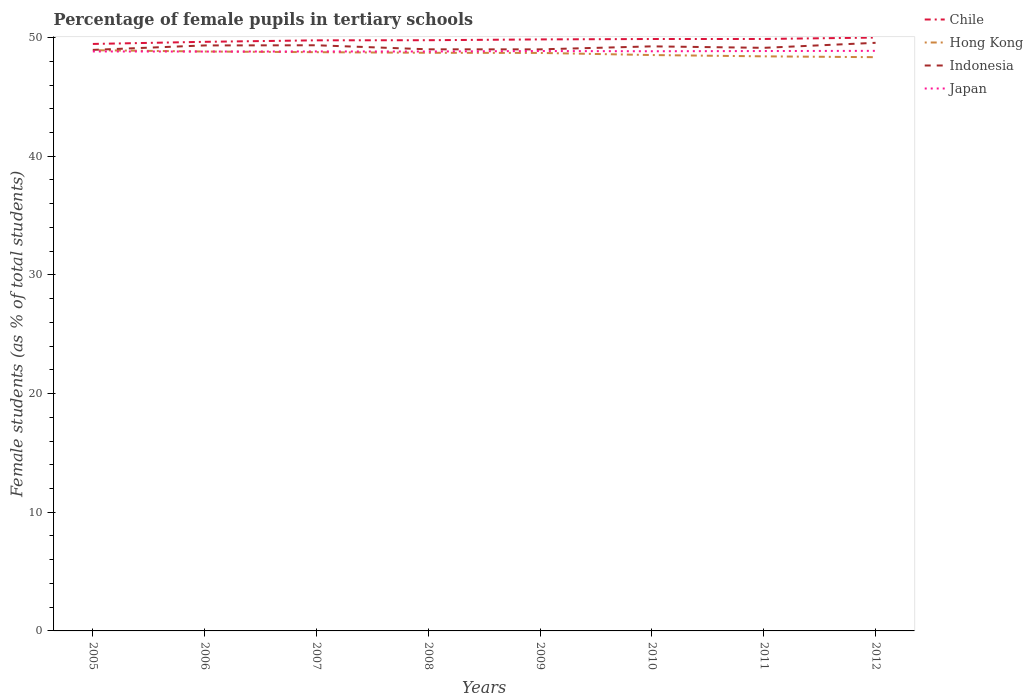How many different coloured lines are there?
Your response must be concise. 4. Across all years, what is the maximum percentage of female pupils in tertiary schools in Japan?
Offer a terse response. 48.82. In which year was the percentage of female pupils in tertiary schools in Japan maximum?
Keep it short and to the point. 2006. What is the total percentage of female pupils in tertiary schools in Indonesia in the graph?
Provide a succinct answer. -0.22. What is the difference between the highest and the second highest percentage of female pupils in tertiary schools in Japan?
Provide a succinct answer. 0.06. What is the difference between the highest and the lowest percentage of female pupils in tertiary schools in Japan?
Give a very brief answer. 4. What is the difference between two consecutive major ticks on the Y-axis?
Provide a succinct answer. 10. Are the values on the major ticks of Y-axis written in scientific E-notation?
Offer a very short reply. No. Does the graph contain any zero values?
Give a very brief answer. No. Does the graph contain grids?
Keep it short and to the point. No. What is the title of the graph?
Your answer should be very brief. Percentage of female pupils in tertiary schools. Does "Tajikistan" appear as one of the legend labels in the graph?
Provide a succinct answer. No. What is the label or title of the X-axis?
Provide a short and direct response. Years. What is the label or title of the Y-axis?
Make the answer very short. Female students (as % of total students). What is the Female students (as % of total students) in Chile in 2005?
Ensure brevity in your answer.  49.46. What is the Female students (as % of total students) of Hong Kong in 2005?
Your response must be concise. 48.94. What is the Female students (as % of total students) of Indonesia in 2005?
Give a very brief answer. 48.96. What is the Female students (as % of total students) of Japan in 2005?
Provide a succinct answer. 48.83. What is the Female students (as % of total students) in Chile in 2006?
Provide a succinct answer. 49.64. What is the Female students (as % of total students) of Hong Kong in 2006?
Offer a very short reply. 48.82. What is the Female students (as % of total students) in Indonesia in 2006?
Your response must be concise. 49.34. What is the Female students (as % of total students) in Japan in 2006?
Give a very brief answer. 48.82. What is the Female students (as % of total students) of Chile in 2007?
Your answer should be compact. 49.77. What is the Female students (as % of total students) in Hong Kong in 2007?
Your answer should be compact. 48.77. What is the Female students (as % of total students) in Indonesia in 2007?
Your answer should be very brief. 49.35. What is the Female students (as % of total students) in Japan in 2007?
Your answer should be compact. 48.83. What is the Female students (as % of total students) of Chile in 2008?
Offer a terse response. 49.78. What is the Female students (as % of total students) in Hong Kong in 2008?
Provide a short and direct response. 48.72. What is the Female students (as % of total students) in Indonesia in 2008?
Your response must be concise. 49.01. What is the Female students (as % of total students) in Japan in 2008?
Provide a short and direct response. 48.83. What is the Female students (as % of total students) in Chile in 2009?
Your answer should be very brief. 49.84. What is the Female students (as % of total students) in Hong Kong in 2009?
Your answer should be compact. 48.71. What is the Female students (as % of total students) in Indonesia in 2009?
Provide a succinct answer. 49.01. What is the Female students (as % of total students) in Japan in 2009?
Provide a succinct answer. 48.87. What is the Female students (as % of total students) in Chile in 2010?
Your answer should be compact. 49.88. What is the Female students (as % of total students) of Hong Kong in 2010?
Provide a succinct answer. 48.53. What is the Female students (as % of total students) in Indonesia in 2010?
Your answer should be compact. 49.26. What is the Female students (as % of total students) in Japan in 2010?
Your response must be concise. 48.85. What is the Female students (as % of total students) in Chile in 2011?
Give a very brief answer. 49.88. What is the Female students (as % of total students) of Hong Kong in 2011?
Keep it short and to the point. 48.42. What is the Female students (as % of total students) in Indonesia in 2011?
Your answer should be compact. 49.13. What is the Female students (as % of total students) of Japan in 2011?
Offer a terse response. 48.87. What is the Female students (as % of total students) in Chile in 2012?
Offer a very short reply. 50. What is the Female students (as % of total students) in Hong Kong in 2012?
Your answer should be very brief. 48.35. What is the Female students (as % of total students) of Indonesia in 2012?
Offer a very short reply. 49.56. What is the Female students (as % of total students) in Japan in 2012?
Keep it short and to the point. 48.88. Across all years, what is the maximum Female students (as % of total students) in Chile?
Provide a succinct answer. 50. Across all years, what is the maximum Female students (as % of total students) of Hong Kong?
Provide a short and direct response. 48.94. Across all years, what is the maximum Female students (as % of total students) in Indonesia?
Give a very brief answer. 49.56. Across all years, what is the maximum Female students (as % of total students) of Japan?
Provide a succinct answer. 48.88. Across all years, what is the minimum Female students (as % of total students) of Chile?
Give a very brief answer. 49.46. Across all years, what is the minimum Female students (as % of total students) of Hong Kong?
Offer a very short reply. 48.35. Across all years, what is the minimum Female students (as % of total students) in Indonesia?
Your answer should be very brief. 48.96. Across all years, what is the minimum Female students (as % of total students) in Japan?
Ensure brevity in your answer.  48.82. What is the total Female students (as % of total students) in Chile in the graph?
Ensure brevity in your answer.  398.25. What is the total Female students (as % of total students) of Hong Kong in the graph?
Give a very brief answer. 389.24. What is the total Female students (as % of total students) in Indonesia in the graph?
Offer a very short reply. 393.62. What is the total Female students (as % of total students) in Japan in the graph?
Ensure brevity in your answer.  390.77. What is the difference between the Female students (as % of total students) in Chile in 2005 and that in 2006?
Your answer should be very brief. -0.18. What is the difference between the Female students (as % of total students) in Hong Kong in 2005 and that in 2006?
Ensure brevity in your answer.  0.11. What is the difference between the Female students (as % of total students) of Indonesia in 2005 and that in 2006?
Make the answer very short. -0.37. What is the difference between the Female students (as % of total students) of Japan in 2005 and that in 2006?
Offer a terse response. 0.01. What is the difference between the Female students (as % of total students) of Chile in 2005 and that in 2007?
Provide a short and direct response. -0.3. What is the difference between the Female students (as % of total students) of Hong Kong in 2005 and that in 2007?
Your answer should be compact. 0.17. What is the difference between the Female students (as % of total students) in Indonesia in 2005 and that in 2007?
Ensure brevity in your answer.  -0.39. What is the difference between the Female students (as % of total students) in Japan in 2005 and that in 2007?
Ensure brevity in your answer.  -0. What is the difference between the Female students (as % of total students) of Chile in 2005 and that in 2008?
Your response must be concise. -0.31. What is the difference between the Female students (as % of total students) in Hong Kong in 2005 and that in 2008?
Offer a terse response. 0.22. What is the difference between the Female students (as % of total students) in Indonesia in 2005 and that in 2008?
Ensure brevity in your answer.  -0.05. What is the difference between the Female students (as % of total students) in Japan in 2005 and that in 2008?
Give a very brief answer. 0. What is the difference between the Female students (as % of total students) in Chile in 2005 and that in 2009?
Offer a very short reply. -0.38. What is the difference between the Female students (as % of total students) in Hong Kong in 2005 and that in 2009?
Your answer should be very brief. 0.23. What is the difference between the Female students (as % of total students) in Indonesia in 2005 and that in 2009?
Your response must be concise. -0.04. What is the difference between the Female students (as % of total students) in Japan in 2005 and that in 2009?
Offer a terse response. -0.03. What is the difference between the Female students (as % of total students) in Chile in 2005 and that in 2010?
Give a very brief answer. -0.42. What is the difference between the Female students (as % of total students) of Hong Kong in 2005 and that in 2010?
Provide a short and direct response. 0.41. What is the difference between the Female students (as % of total students) of Indonesia in 2005 and that in 2010?
Your response must be concise. -0.3. What is the difference between the Female students (as % of total students) in Japan in 2005 and that in 2010?
Give a very brief answer. -0.02. What is the difference between the Female students (as % of total students) of Chile in 2005 and that in 2011?
Keep it short and to the point. -0.42. What is the difference between the Female students (as % of total students) in Hong Kong in 2005 and that in 2011?
Make the answer very short. 0.52. What is the difference between the Female students (as % of total students) of Indonesia in 2005 and that in 2011?
Give a very brief answer. -0.17. What is the difference between the Female students (as % of total students) in Japan in 2005 and that in 2011?
Your answer should be compact. -0.03. What is the difference between the Female students (as % of total students) of Chile in 2005 and that in 2012?
Provide a short and direct response. -0.54. What is the difference between the Female students (as % of total students) of Hong Kong in 2005 and that in 2012?
Your response must be concise. 0.59. What is the difference between the Female students (as % of total students) of Indonesia in 2005 and that in 2012?
Give a very brief answer. -0.6. What is the difference between the Female students (as % of total students) of Japan in 2005 and that in 2012?
Keep it short and to the point. -0.05. What is the difference between the Female students (as % of total students) of Chile in 2006 and that in 2007?
Your response must be concise. -0.13. What is the difference between the Female students (as % of total students) in Hong Kong in 2006 and that in 2007?
Your answer should be compact. 0.06. What is the difference between the Female students (as % of total students) of Indonesia in 2006 and that in 2007?
Offer a terse response. -0.01. What is the difference between the Female students (as % of total students) of Japan in 2006 and that in 2007?
Your response must be concise. -0.01. What is the difference between the Female students (as % of total students) in Chile in 2006 and that in 2008?
Your answer should be compact. -0.14. What is the difference between the Female students (as % of total students) in Hong Kong in 2006 and that in 2008?
Keep it short and to the point. 0.11. What is the difference between the Female students (as % of total students) of Indonesia in 2006 and that in 2008?
Provide a succinct answer. 0.33. What is the difference between the Female students (as % of total students) in Japan in 2006 and that in 2008?
Your response must be concise. -0. What is the difference between the Female students (as % of total students) in Chile in 2006 and that in 2009?
Your answer should be very brief. -0.2. What is the difference between the Female students (as % of total students) of Hong Kong in 2006 and that in 2009?
Keep it short and to the point. 0.12. What is the difference between the Female students (as % of total students) in Indonesia in 2006 and that in 2009?
Provide a succinct answer. 0.33. What is the difference between the Female students (as % of total students) of Japan in 2006 and that in 2009?
Provide a short and direct response. -0.04. What is the difference between the Female students (as % of total students) of Chile in 2006 and that in 2010?
Offer a terse response. -0.24. What is the difference between the Female students (as % of total students) of Hong Kong in 2006 and that in 2010?
Offer a very short reply. 0.3. What is the difference between the Female students (as % of total students) of Indonesia in 2006 and that in 2010?
Your answer should be very brief. 0.08. What is the difference between the Female students (as % of total students) of Japan in 2006 and that in 2010?
Your response must be concise. -0.02. What is the difference between the Female students (as % of total students) in Chile in 2006 and that in 2011?
Ensure brevity in your answer.  -0.24. What is the difference between the Female students (as % of total students) in Hong Kong in 2006 and that in 2011?
Your answer should be compact. 0.41. What is the difference between the Female students (as % of total students) of Indonesia in 2006 and that in 2011?
Keep it short and to the point. 0.2. What is the difference between the Female students (as % of total students) of Japan in 2006 and that in 2011?
Keep it short and to the point. -0.04. What is the difference between the Female students (as % of total students) of Chile in 2006 and that in 2012?
Offer a very short reply. -0.36. What is the difference between the Female students (as % of total students) in Hong Kong in 2006 and that in 2012?
Offer a very short reply. 0.48. What is the difference between the Female students (as % of total students) in Indonesia in 2006 and that in 2012?
Your answer should be very brief. -0.22. What is the difference between the Female students (as % of total students) of Japan in 2006 and that in 2012?
Make the answer very short. -0.06. What is the difference between the Female students (as % of total students) in Chile in 2007 and that in 2008?
Offer a very short reply. -0.01. What is the difference between the Female students (as % of total students) in Hong Kong in 2007 and that in 2008?
Your answer should be compact. 0.05. What is the difference between the Female students (as % of total students) of Indonesia in 2007 and that in 2008?
Your response must be concise. 0.34. What is the difference between the Female students (as % of total students) of Japan in 2007 and that in 2008?
Keep it short and to the point. 0.01. What is the difference between the Female students (as % of total students) of Chile in 2007 and that in 2009?
Your answer should be compact. -0.08. What is the difference between the Female students (as % of total students) of Hong Kong in 2007 and that in 2009?
Provide a succinct answer. 0.06. What is the difference between the Female students (as % of total students) of Indonesia in 2007 and that in 2009?
Provide a short and direct response. 0.34. What is the difference between the Female students (as % of total students) of Japan in 2007 and that in 2009?
Give a very brief answer. -0.03. What is the difference between the Female students (as % of total students) of Chile in 2007 and that in 2010?
Offer a terse response. -0.11. What is the difference between the Female students (as % of total students) in Hong Kong in 2007 and that in 2010?
Provide a succinct answer. 0.24. What is the difference between the Female students (as % of total students) in Indonesia in 2007 and that in 2010?
Offer a very short reply. 0.09. What is the difference between the Female students (as % of total students) of Japan in 2007 and that in 2010?
Keep it short and to the point. -0.01. What is the difference between the Female students (as % of total students) in Chile in 2007 and that in 2011?
Give a very brief answer. -0.11. What is the difference between the Female students (as % of total students) of Hong Kong in 2007 and that in 2011?
Provide a short and direct response. 0.35. What is the difference between the Female students (as % of total students) in Indonesia in 2007 and that in 2011?
Ensure brevity in your answer.  0.22. What is the difference between the Female students (as % of total students) of Japan in 2007 and that in 2011?
Give a very brief answer. -0.03. What is the difference between the Female students (as % of total students) of Chile in 2007 and that in 2012?
Keep it short and to the point. -0.23. What is the difference between the Female students (as % of total students) of Hong Kong in 2007 and that in 2012?
Keep it short and to the point. 0.42. What is the difference between the Female students (as % of total students) in Indonesia in 2007 and that in 2012?
Offer a terse response. -0.21. What is the difference between the Female students (as % of total students) in Japan in 2007 and that in 2012?
Offer a very short reply. -0.05. What is the difference between the Female students (as % of total students) of Chile in 2008 and that in 2009?
Keep it short and to the point. -0.07. What is the difference between the Female students (as % of total students) in Hong Kong in 2008 and that in 2009?
Ensure brevity in your answer.  0.01. What is the difference between the Female students (as % of total students) in Indonesia in 2008 and that in 2009?
Your answer should be very brief. 0. What is the difference between the Female students (as % of total students) in Japan in 2008 and that in 2009?
Keep it short and to the point. -0.04. What is the difference between the Female students (as % of total students) of Chile in 2008 and that in 2010?
Give a very brief answer. -0.1. What is the difference between the Female students (as % of total students) in Hong Kong in 2008 and that in 2010?
Make the answer very short. 0.19. What is the difference between the Female students (as % of total students) in Indonesia in 2008 and that in 2010?
Offer a very short reply. -0.25. What is the difference between the Female students (as % of total students) in Japan in 2008 and that in 2010?
Offer a terse response. -0.02. What is the difference between the Female students (as % of total students) of Chile in 2008 and that in 2011?
Make the answer very short. -0.1. What is the difference between the Female students (as % of total students) in Hong Kong in 2008 and that in 2011?
Keep it short and to the point. 0.3. What is the difference between the Female students (as % of total students) in Indonesia in 2008 and that in 2011?
Keep it short and to the point. -0.12. What is the difference between the Female students (as % of total students) of Japan in 2008 and that in 2011?
Keep it short and to the point. -0.04. What is the difference between the Female students (as % of total students) in Chile in 2008 and that in 2012?
Your response must be concise. -0.22. What is the difference between the Female students (as % of total students) of Hong Kong in 2008 and that in 2012?
Give a very brief answer. 0.37. What is the difference between the Female students (as % of total students) of Indonesia in 2008 and that in 2012?
Your answer should be very brief. -0.55. What is the difference between the Female students (as % of total students) of Japan in 2008 and that in 2012?
Your answer should be very brief. -0.05. What is the difference between the Female students (as % of total students) in Chile in 2009 and that in 2010?
Ensure brevity in your answer.  -0.03. What is the difference between the Female students (as % of total students) of Hong Kong in 2009 and that in 2010?
Make the answer very short. 0.18. What is the difference between the Female students (as % of total students) of Indonesia in 2009 and that in 2010?
Your response must be concise. -0.25. What is the difference between the Female students (as % of total students) in Japan in 2009 and that in 2010?
Provide a succinct answer. 0.02. What is the difference between the Female students (as % of total students) of Chile in 2009 and that in 2011?
Your answer should be compact. -0.04. What is the difference between the Female students (as % of total students) of Hong Kong in 2009 and that in 2011?
Keep it short and to the point. 0.29. What is the difference between the Female students (as % of total students) in Indonesia in 2009 and that in 2011?
Offer a terse response. -0.13. What is the difference between the Female students (as % of total students) of Japan in 2009 and that in 2011?
Your answer should be compact. 0. What is the difference between the Female students (as % of total students) of Chile in 2009 and that in 2012?
Provide a succinct answer. -0.16. What is the difference between the Female students (as % of total students) in Hong Kong in 2009 and that in 2012?
Offer a terse response. 0.36. What is the difference between the Female students (as % of total students) of Indonesia in 2009 and that in 2012?
Offer a terse response. -0.55. What is the difference between the Female students (as % of total students) in Japan in 2009 and that in 2012?
Your answer should be very brief. -0.02. What is the difference between the Female students (as % of total students) in Chile in 2010 and that in 2011?
Offer a terse response. -0. What is the difference between the Female students (as % of total students) in Hong Kong in 2010 and that in 2011?
Your answer should be very brief. 0.11. What is the difference between the Female students (as % of total students) of Indonesia in 2010 and that in 2011?
Provide a succinct answer. 0.12. What is the difference between the Female students (as % of total students) of Japan in 2010 and that in 2011?
Offer a terse response. -0.02. What is the difference between the Female students (as % of total students) of Chile in 2010 and that in 2012?
Provide a short and direct response. -0.12. What is the difference between the Female students (as % of total students) of Hong Kong in 2010 and that in 2012?
Ensure brevity in your answer.  0.18. What is the difference between the Female students (as % of total students) in Indonesia in 2010 and that in 2012?
Keep it short and to the point. -0.3. What is the difference between the Female students (as % of total students) in Japan in 2010 and that in 2012?
Keep it short and to the point. -0.03. What is the difference between the Female students (as % of total students) in Chile in 2011 and that in 2012?
Your response must be concise. -0.12. What is the difference between the Female students (as % of total students) in Hong Kong in 2011 and that in 2012?
Keep it short and to the point. 0.07. What is the difference between the Female students (as % of total students) in Indonesia in 2011 and that in 2012?
Make the answer very short. -0.42. What is the difference between the Female students (as % of total students) of Japan in 2011 and that in 2012?
Provide a succinct answer. -0.02. What is the difference between the Female students (as % of total students) in Chile in 2005 and the Female students (as % of total students) in Hong Kong in 2006?
Ensure brevity in your answer.  0.64. What is the difference between the Female students (as % of total students) in Chile in 2005 and the Female students (as % of total students) in Indonesia in 2006?
Your answer should be very brief. 0.12. What is the difference between the Female students (as % of total students) of Chile in 2005 and the Female students (as % of total students) of Japan in 2006?
Provide a succinct answer. 0.64. What is the difference between the Female students (as % of total students) of Hong Kong in 2005 and the Female students (as % of total students) of Indonesia in 2006?
Give a very brief answer. -0.4. What is the difference between the Female students (as % of total students) of Hong Kong in 2005 and the Female students (as % of total students) of Japan in 2006?
Give a very brief answer. 0.11. What is the difference between the Female students (as % of total students) in Indonesia in 2005 and the Female students (as % of total students) in Japan in 2006?
Make the answer very short. 0.14. What is the difference between the Female students (as % of total students) in Chile in 2005 and the Female students (as % of total students) in Hong Kong in 2007?
Provide a short and direct response. 0.69. What is the difference between the Female students (as % of total students) of Chile in 2005 and the Female students (as % of total students) of Japan in 2007?
Make the answer very short. 0.63. What is the difference between the Female students (as % of total students) in Hong Kong in 2005 and the Female students (as % of total students) in Indonesia in 2007?
Give a very brief answer. -0.42. What is the difference between the Female students (as % of total students) in Hong Kong in 2005 and the Female students (as % of total students) in Japan in 2007?
Give a very brief answer. 0.1. What is the difference between the Female students (as % of total students) in Indonesia in 2005 and the Female students (as % of total students) in Japan in 2007?
Ensure brevity in your answer.  0.13. What is the difference between the Female students (as % of total students) of Chile in 2005 and the Female students (as % of total students) of Hong Kong in 2008?
Your response must be concise. 0.74. What is the difference between the Female students (as % of total students) of Chile in 2005 and the Female students (as % of total students) of Indonesia in 2008?
Provide a succinct answer. 0.45. What is the difference between the Female students (as % of total students) of Chile in 2005 and the Female students (as % of total students) of Japan in 2008?
Provide a short and direct response. 0.64. What is the difference between the Female students (as % of total students) in Hong Kong in 2005 and the Female students (as % of total students) in Indonesia in 2008?
Your response must be concise. -0.07. What is the difference between the Female students (as % of total students) of Hong Kong in 2005 and the Female students (as % of total students) of Japan in 2008?
Your answer should be compact. 0.11. What is the difference between the Female students (as % of total students) in Indonesia in 2005 and the Female students (as % of total students) in Japan in 2008?
Keep it short and to the point. 0.14. What is the difference between the Female students (as % of total students) of Chile in 2005 and the Female students (as % of total students) of Hong Kong in 2009?
Provide a short and direct response. 0.76. What is the difference between the Female students (as % of total students) in Chile in 2005 and the Female students (as % of total students) in Indonesia in 2009?
Ensure brevity in your answer.  0.46. What is the difference between the Female students (as % of total students) of Chile in 2005 and the Female students (as % of total students) of Japan in 2009?
Your answer should be compact. 0.6. What is the difference between the Female students (as % of total students) of Hong Kong in 2005 and the Female students (as % of total students) of Indonesia in 2009?
Give a very brief answer. -0.07. What is the difference between the Female students (as % of total students) of Hong Kong in 2005 and the Female students (as % of total students) of Japan in 2009?
Your answer should be very brief. 0.07. What is the difference between the Female students (as % of total students) in Indonesia in 2005 and the Female students (as % of total students) in Japan in 2009?
Ensure brevity in your answer.  0.1. What is the difference between the Female students (as % of total students) in Chile in 2005 and the Female students (as % of total students) in Hong Kong in 2010?
Ensure brevity in your answer.  0.93. What is the difference between the Female students (as % of total students) in Chile in 2005 and the Female students (as % of total students) in Indonesia in 2010?
Provide a succinct answer. 0.2. What is the difference between the Female students (as % of total students) in Chile in 2005 and the Female students (as % of total students) in Japan in 2010?
Provide a succinct answer. 0.62. What is the difference between the Female students (as % of total students) in Hong Kong in 2005 and the Female students (as % of total students) in Indonesia in 2010?
Offer a very short reply. -0.32. What is the difference between the Female students (as % of total students) in Hong Kong in 2005 and the Female students (as % of total students) in Japan in 2010?
Give a very brief answer. 0.09. What is the difference between the Female students (as % of total students) in Indonesia in 2005 and the Female students (as % of total students) in Japan in 2010?
Offer a very short reply. 0.12. What is the difference between the Female students (as % of total students) of Chile in 2005 and the Female students (as % of total students) of Hong Kong in 2011?
Offer a terse response. 1.04. What is the difference between the Female students (as % of total students) in Chile in 2005 and the Female students (as % of total students) in Indonesia in 2011?
Your response must be concise. 0.33. What is the difference between the Female students (as % of total students) in Chile in 2005 and the Female students (as % of total students) in Japan in 2011?
Your answer should be compact. 0.6. What is the difference between the Female students (as % of total students) of Hong Kong in 2005 and the Female students (as % of total students) of Indonesia in 2011?
Give a very brief answer. -0.2. What is the difference between the Female students (as % of total students) of Hong Kong in 2005 and the Female students (as % of total students) of Japan in 2011?
Your response must be concise. 0.07. What is the difference between the Female students (as % of total students) in Indonesia in 2005 and the Female students (as % of total students) in Japan in 2011?
Give a very brief answer. 0.1. What is the difference between the Female students (as % of total students) of Chile in 2005 and the Female students (as % of total students) of Hong Kong in 2012?
Offer a terse response. 1.11. What is the difference between the Female students (as % of total students) of Chile in 2005 and the Female students (as % of total students) of Indonesia in 2012?
Your answer should be very brief. -0.1. What is the difference between the Female students (as % of total students) of Chile in 2005 and the Female students (as % of total students) of Japan in 2012?
Give a very brief answer. 0.58. What is the difference between the Female students (as % of total students) in Hong Kong in 2005 and the Female students (as % of total students) in Indonesia in 2012?
Offer a terse response. -0.62. What is the difference between the Female students (as % of total students) in Hong Kong in 2005 and the Female students (as % of total students) in Japan in 2012?
Provide a succinct answer. 0.06. What is the difference between the Female students (as % of total students) of Indonesia in 2005 and the Female students (as % of total students) of Japan in 2012?
Ensure brevity in your answer.  0.08. What is the difference between the Female students (as % of total students) of Chile in 2006 and the Female students (as % of total students) of Hong Kong in 2007?
Ensure brevity in your answer.  0.87. What is the difference between the Female students (as % of total students) in Chile in 2006 and the Female students (as % of total students) in Indonesia in 2007?
Your answer should be very brief. 0.29. What is the difference between the Female students (as % of total students) of Chile in 2006 and the Female students (as % of total students) of Japan in 2007?
Offer a terse response. 0.81. What is the difference between the Female students (as % of total students) of Hong Kong in 2006 and the Female students (as % of total students) of Indonesia in 2007?
Offer a terse response. -0.53. What is the difference between the Female students (as % of total students) in Hong Kong in 2006 and the Female students (as % of total students) in Japan in 2007?
Your response must be concise. -0.01. What is the difference between the Female students (as % of total students) in Indonesia in 2006 and the Female students (as % of total students) in Japan in 2007?
Give a very brief answer. 0.51. What is the difference between the Female students (as % of total students) of Chile in 2006 and the Female students (as % of total students) of Hong Kong in 2008?
Give a very brief answer. 0.92. What is the difference between the Female students (as % of total students) in Chile in 2006 and the Female students (as % of total students) in Indonesia in 2008?
Your response must be concise. 0.63. What is the difference between the Female students (as % of total students) of Chile in 2006 and the Female students (as % of total students) of Japan in 2008?
Offer a very short reply. 0.82. What is the difference between the Female students (as % of total students) in Hong Kong in 2006 and the Female students (as % of total students) in Indonesia in 2008?
Provide a succinct answer. -0.19. What is the difference between the Female students (as % of total students) in Hong Kong in 2006 and the Female students (as % of total students) in Japan in 2008?
Ensure brevity in your answer.  -0. What is the difference between the Female students (as % of total students) in Indonesia in 2006 and the Female students (as % of total students) in Japan in 2008?
Provide a short and direct response. 0.51. What is the difference between the Female students (as % of total students) in Chile in 2006 and the Female students (as % of total students) in Hong Kong in 2009?
Provide a short and direct response. 0.94. What is the difference between the Female students (as % of total students) of Chile in 2006 and the Female students (as % of total students) of Indonesia in 2009?
Your answer should be very brief. 0.64. What is the difference between the Female students (as % of total students) of Chile in 2006 and the Female students (as % of total students) of Japan in 2009?
Offer a terse response. 0.78. What is the difference between the Female students (as % of total students) of Hong Kong in 2006 and the Female students (as % of total students) of Indonesia in 2009?
Offer a very short reply. -0.18. What is the difference between the Female students (as % of total students) in Hong Kong in 2006 and the Female students (as % of total students) in Japan in 2009?
Your response must be concise. -0.04. What is the difference between the Female students (as % of total students) of Indonesia in 2006 and the Female students (as % of total students) of Japan in 2009?
Give a very brief answer. 0.47. What is the difference between the Female students (as % of total students) of Chile in 2006 and the Female students (as % of total students) of Hong Kong in 2010?
Your answer should be very brief. 1.11. What is the difference between the Female students (as % of total students) in Chile in 2006 and the Female students (as % of total students) in Indonesia in 2010?
Your response must be concise. 0.38. What is the difference between the Female students (as % of total students) of Chile in 2006 and the Female students (as % of total students) of Japan in 2010?
Your answer should be compact. 0.8. What is the difference between the Female students (as % of total students) of Hong Kong in 2006 and the Female students (as % of total students) of Indonesia in 2010?
Make the answer very short. -0.43. What is the difference between the Female students (as % of total students) of Hong Kong in 2006 and the Female students (as % of total students) of Japan in 2010?
Provide a succinct answer. -0.02. What is the difference between the Female students (as % of total students) of Indonesia in 2006 and the Female students (as % of total students) of Japan in 2010?
Provide a succinct answer. 0.49. What is the difference between the Female students (as % of total students) in Chile in 2006 and the Female students (as % of total students) in Hong Kong in 2011?
Your response must be concise. 1.22. What is the difference between the Female students (as % of total students) of Chile in 2006 and the Female students (as % of total students) of Indonesia in 2011?
Provide a succinct answer. 0.51. What is the difference between the Female students (as % of total students) in Chile in 2006 and the Female students (as % of total students) in Japan in 2011?
Provide a short and direct response. 0.78. What is the difference between the Female students (as % of total students) in Hong Kong in 2006 and the Female students (as % of total students) in Indonesia in 2011?
Provide a succinct answer. -0.31. What is the difference between the Female students (as % of total students) in Hong Kong in 2006 and the Female students (as % of total students) in Japan in 2011?
Keep it short and to the point. -0.04. What is the difference between the Female students (as % of total students) in Indonesia in 2006 and the Female students (as % of total students) in Japan in 2011?
Your answer should be compact. 0.47. What is the difference between the Female students (as % of total students) in Chile in 2006 and the Female students (as % of total students) in Hong Kong in 2012?
Give a very brief answer. 1.29. What is the difference between the Female students (as % of total students) of Chile in 2006 and the Female students (as % of total students) of Indonesia in 2012?
Keep it short and to the point. 0.08. What is the difference between the Female students (as % of total students) of Chile in 2006 and the Female students (as % of total students) of Japan in 2012?
Give a very brief answer. 0.76. What is the difference between the Female students (as % of total students) of Hong Kong in 2006 and the Female students (as % of total students) of Indonesia in 2012?
Give a very brief answer. -0.73. What is the difference between the Female students (as % of total students) in Hong Kong in 2006 and the Female students (as % of total students) in Japan in 2012?
Your answer should be very brief. -0.06. What is the difference between the Female students (as % of total students) of Indonesia in 2006 and the Female students (as % of total students) of Japan in 2012?
Your answer should be very brief. 0.46. What is the difference between the Female students (as % of total students) of Chile in 2007 and the Female students (as % of total students) of Hong Kong in 2008?
Provide a succinct answer. 1.05. What is the difference between the Female students (as % of total students) of Chile in 2007 and the Female students (as % of total students) of Indonesia in 2008?
Offer a very short reply. 0.76. What is the difference between the Female students (as % of total students) in Chile in 2007 and the Female students (as % of total students) in Japan in 2008?
Provide a succinct answer. 0.94. What is the difference between the Female students (as % of total students) in Hong Kong in 2007 and the Female students (as % of total students) in Indonesia in 2008?
Provide a succinct answer. -0.24. What is the difference between the Female students (as % of total students) of Hong Kong in 2007 and the Female students (as % of total students) of Japan in 2008?
Offer a terse response. -0.06. What is the difference between the Female students (as % of total students) of Indonesia in 2007 and the Female students (as % of total students) of Japan in 2008?
Keep it short and to the point. 0.52. What is the difference between the Female students (as % of total students) in Chile in 2007 and the Female students (as % of total students) in Hong Kong in 2009?
Give a very brief answer. 1.06. What is the difference between the Female students (as % of total students) of Chile in 2007 and the Female students (as % of total students) of Indonesia in 2009?
Provide a short and direct response. 0.76. What is the difference between the Female students (as % of total students) in Chile in 2007 and the Female students (as % of total students) in Japan in 2009?
Your response must be concise. 0.9. What is the difference between the Female students (as % of total students) of Hong Kong in 2007 and the Female students (as % of total students) of Indonesia in 2009?
Offer a terse response. -0.24. What is the difference between the Female students (as % of total students) of Hong Kong in 2007 and the Female students (as % of total students) of Japan in 2009?
Keep it short and to the point. -0.1. What is the difference between the Female students (as % of total students) in Indonesia in 2007 and the Female students (as % of total students) in Japan in 2009?
Keep it short and to the point. 0.49. What is the difference between the Female students (as % of total students) in Chile in 2007 and the Female students (as % of total students) in Hong Kong in 2010?
Your answer should be compact. 1.24. What is the difference between the Female students (as % of total students) in Chile in 2007 and the Female students (as % of total students) in Indonesia in 2010?
Offer a terse response. 0.51. What is the difference between the Female students (as % of total students) in Chile in 2007 and the Female students (as % of total students) in Japan in 2010?
Offer a very short reply. 0.92. What is the difference between the Female students (as % of total students) in Hong Kong in 2007 and the Female students (as % of total students) in Indonesia in 2010?
Offer a terse response. -0.49. What is the difference between the Female students (as % of total students) in Hong Kong in 2007 and the Female students (as % of total students) in Japan in 2010?
Make the answer very short. -0.08. What is the difference between the Female students (as % of total students) in Indonesia in 2007 and the Female students (as % of total students) in Japan in 2010?
Your answer should be compact. 0.5. What is the difference between the Female students (as % of total students) in Chile in 2007 and the Female students (as % of total students) in Hong Kong in 2011?
Your answer should be compact. 1.35. What is the difference between the Female students (as % of total students) in Chile in 2007 and the Female students (as % of total students) in Indonesia in 2011?
Ensure brevity in your answer.  0.63. What is the difference between the Female students (as % of total students) in Chile in 2007 and the Female students (as % of total students) in Japan in 2011?
Provide a short and direct response. 0.9. What is the difference between the Female students (as % of total students) in Hong Kong in 2007 and the Female students (as % of total students) in Indonesia in 2011?
Keep it short and to the point. -0.37. What is the difference between the Female students (as % of total students) in Hong Kong in 2007 and the Female students (as % of total students) in Japan in 2011?
Give a very brief answer. -0.1. What is the difference between the Female students (as % of total students) of Indonesia in 2007 and the Female students (as % of total students) of Japan in 2011?
Provide a short and direct response. 0.49. What is the difference between the Female students (as % of total students) of Chile in 2007 and the Female students (as % of total students) of Hong Kong in 2012?
Your response must be concise. 1.42. What is the difference between the Female students (as % of total students) in Chile in 2007 and the Female students (as % of total students) in Indonesia in 2012?
Keep it short and to the point. 0.21. What is the difference between the Female students (as % of total students) of Chile in 2007 and the Female students (as % of total students) of Japan in 2012?
Provide a succinct answer. 0.89. What is the difference between the Female students (as % of total students) in Hong Kong in 2007 and the Female students (as % of total students) in Indonesia in 2012?
Offer a terse response. -0.79. What is the difference between the Female students (as % of total students) of Hong Kong in 2007 and the Female students (as % of total students) of Japan in 2012?
Your answer should be compact. -0.11. What is the difference between the Female students (as % of total students) of Indonesia in 2007 and the Female students (as % of total students) of Japan in 2012?
Ensure brevity in your answer.  0.47. What is the difference between the Female students (as % of total students) in Chile in 2008 and the Female students (as % of total students) in Hong Kong in 2009?
Offer a terse response. 1.07. What is the difference between the Female students (as % of total students) in Chile in 2008 and the Female students (as % of total students) in Indonesia in 2009?
Make the answer very short. 0.77. What is the difference between the Female students (as % of total students) in Chile in 2008 and the Female students (as % of total students) in Japan in 2009?
Make the answer very short. 0.91. What is the difference between the Female students (as % of total students) in Hong Kong in 2008 and the Female students (as % of total students) in Indonesia in 2009?
Ensure brevity in your answer.  -0.29. What is the difference between the Female students (as % of total students) in Hong Kong in 2008 and the Female students (as % of total students) in Japan in 2009?
Offer a terse response. -0.15. What is the difference between the Female students (as % of total students) in Indonesia in 2008 and the Female students (as % of total students) in Japan in 2009?
Offer a terse response. 0.14. What is the difference between the Female students (as % of total students) in Chile in 2008 and the Female students (as % of total students) in Hong Kong in 2010?
Provide a succinct answer. 1.25. What is the difference between the Female students (as % of total students) in Chile in 2008 and the Female students (as % of total students) in Indonesia in 2010?
Ensure brevity in your answer.  0.52. What is the difference between the Female students (as % of total students) of Chile in 2008 and the Female students (as % of total students) of Japan in 2010?
Your response must be concise. 0.93. What is the difference between the Female students (as % of total students) in Hong Kong in 2008 and the Female students (as % of total students) in Indonesia in 2010?
Your answer should be compact. -0.54. What is the difference between the Female students (as % of total students) of Hong Kong in 2008 and the Female students (as % of total students) of Japan in 2010?
Give a very brief answer. -0.13. What is the difference between the Female students (as % of total students) in Indonesia in 2008 and the Female students (as % of total students) in Japan in 2010?
Make the answer very short. 0.16. What is the difference between the Female students (as % of total students) of Chile in 2008 and the Female students (as % of total students) of Hong Kong in 2011?
Give a very brief answer. 1.36. What is the difference between the Female students (as % of total students) in Chile in 2008 and the Female students (as % of total students) in Indonesia in 2011?
Keep it short and to the point. 0.64. What is the difference between the Female students (as % of total students) of Chile in 2008 and the Female students (as % of total students) of Japan in 2011?
Provide a short and direct response. 0.91. What is the difference between the Female students (as % of total students) in Hong Kong in 2008 and the Female students (as % of total students) in Indonesia in 2011?
Give a very brief answer. -0.42. What is the difference between the Female students (as % of total students) in Hong Kong in 2008 and the Female students (as % of total students) in Japan in 2011?
Your answer should be very brief. -0.15. What is the difference between the Female students (as % of total students) of Indonesia in 2008 and the Female students (as % of total students) of Japan in 2011?
Offer a terse response. 0.14. What is the difference between the Female students (as % of total students) in Chile in 2008 and the Female students (as % of total students) in Hong Kong in 2012?
Provide a succinct answer. 1.43. What is the difference between the Female students (as % of total students) in Chile in 2008 and the Female students (as % of total students) in Indonesia in 2012?
Give a very brief answer. 0.22. What is the difference between the Female students (as % of total students) in Chile in 2008 and the Female students (as % of total students) in Japan in 2012?
Ensure brevity in your answer.  0.9. What is the difference between the Female students (as % of total students) of Hong Kong in 2008 and the Female students (as % of total students) of Indonesia in 2012?
Give a very brief answer. -0.84. What is the difference between the Female students (as % of total students) in Hong Kong in 2008 and the Female students (as % of total students) in Japan in 2012?
Your answer should be very brief. -0.16. What is the difference between the Female students (as % of total students) in Indonesia in 2008 and the Female students (as % of total students) in Japan in 2012?
Your answer should be compact. 0.13. What is the difference between the Female students (as % of total students) of Chile in 2009 and the Female students (as % of total students) of Hong Kong in 2010?
Your response must be concise. 1.32. What is the difference between the Female students (as % of total students) in Chile in 2009 and the Female students (as % of total students) in Indonesia in 2010?
Give a very brief answer. 0.59. What is the difference between the Female students (as % of total students) of Hong Kong in 2009 and the Female students (as % of total students) of Indonesia in 2010?
Ensure brevity in your answer.  -0.55. What is the difference between the Female students (as % of total students) in Hong Kong in 2009 and the Female students (as % of total students) in Japan in 2010?
Ensure brevity in your answer.  -0.14. What is the difference between the Female students (as % of total students) in Indonesia in 2009 and the Female students (as % of total students) in Japan in 2010?
Your answer should be very brief. 0.16. What is the difference between the Female students (as % of total students) in Chile in 2009 and the Female students (as % of total students) in Hong Kong in 2011?
Make the answer very short. 1.43. What is the difference between the Female students (as % of total students) of Chile in 2009 and the Female students (as % of total students) of Indonesia in 2011?
Offer a terse response. 0.71. What is the difference between the Female students (as % of total students) in Chile in 2009 and the Female students (as % of total students) in Japan in 2011?
Keep it short and to the point. 0.98. What is the difference between the Female students (as % of total students) of Hong Kong in 2009 and the Female students (as % of total students) of Indonesia in 2011?
Offer a terse response. -0.43. What is the difference between the Female students (as % of total students) of Hong Kong in 2009 and the Female students (as % of total students) of Japan in 2011?
Offer a terse response. -0.16. What is the difference between the Female students (as % of total students) in Indonesia in 2009 and the Female students (as % of total students) in Japan in 2011?
Offer a terse response. 0.14. What is the difference between the Female students (as % of total students) of Chile in 2009 and the Female students (as % of total students) of Hong Kong in 2012?
Provide a succinct answer. 1.5. What is the difference between the Female students (as % of total students) of Chile in 2009 and the Female students (as % of total students) of Indonesia in 2012?
Make the answer very short. 0.29. What is the difference between the Female students (as % of total students) of Chile in 2009 and the Female students (as % of total students) of Japan in 2012?
Your answer should be compact. 0.96. What is the difference between the Female students (as % of total students) of Hong Kong in 2009 and the Female students (as % of total students) of Indonesia in 2012?
Make the answer very short. -0.85. What is the difference between the Female students (as % of total students) of Hong Kong in 2009 and the Female students (as % of total students) of Japan in 2012?
Give a very brief answer. -0.18. What is the difference between the Female students (as % of total students) in Indonesia in 2009 and the Female students (as % of total students) in Japan in 2012?
Your answer should be very brief. 0.13. What is the difference between the Female students (as % of total students) of Chile in 2010 and the Female students (as % of total students) of Hong Kong in 2011?
Provide a short and direct response. 1.46. What is the difference between the Female students (as % of total students) of Chile in 2010 and the Female students (as % of total students) of Indonesia in 2011?
Give a very brief answer. 0.74. What is the difference between the Female students (as % of total students) in Chile in 2010 and the Female students (as % of total students) in Japan in 2011?
Give a very brief answer. 1.01. What is the difference between the Female students (as % of total students) in Hong Kong in 2010 and the Female students (as % of total students) in Indonesia in 2011?
Your response must be concise. -0.61. What is the difference between the Female students (as % of total students) in Hong Kong in 2010 and the Female students (as % of total students) in Japan in 2011?
Your answer should be compact. -0.34. What is the difference between the Female students (as % of total students) of Indonesia in 2010 and the Female students (as % of total students) of Japan in 2011?
Your answer should be very brief. 0.39. What is the difference between the Female students (as % of total students) of Chile in 2010 and the Female students (as % of total students) of Hong Kong in 2012?
Ensure brevity in your answer.  1.53. What is the difference between the Female students (as % of total students) of Chile in 2010 and the Female students (as % of total students) of Indonesia in 2012?
Give a very brief answer. 0.32. What is the difference between the Female students (as % of total students) in Hong Kong in 2010 and the Female students (as % of total students) in Indonesia in 2012?
Offer a terse response. -1.03. What is the difference between the Female students (as % of total students) of Hong Kong in 2010 and the Female students (as % of total students) of Japan in 2012?
Keep it short and to the point. -0.35. What is the difference between the Female students (as % of total students) in Indonesia in 2010 and the Female students (as % of total students) in Japan in 2012?
Your answer should be compact. 0.38. What is the difference between the Female students (as % of total students) in Chile in 2011 and the Female students (as % of total students) in Hong Kong in 2012?
Keep it short and to the point. 1.53. What is the difference between the Female students (as % of total students) in Chile in 2011 and the Female students (as % of total students) in Indonesia in 2012?
Offer a terse response. 0.32. What is the difference between the Female students (as % of total students) of Hong Kong in 2011 and the Female students (as % of total students) of Indonesia in 2012?
Offer a terse response. -1.14. What is the difference between the Female students (as % of total students) of Hong Kong in 2011 and the Female students (as % of total students) of Japan in 2012?
Provide a succinct answer. -0.46. What is the difference between the Female students (as % of total students) of Indonesia in 2011 and the Female students (as % of total students) of Japan in 2012?
Provide a succinct answer. 0.25. What is the average Female students (as % of total students) of Chile per year?
Your answer should be compact. 49.78. What is the average Female students (as % of total students) in Hong Kong per year?
Offer a terse response. 48.66. What is the average Female students (as % of total students) of Indonesia per year?
Offer a terse response. 49.2. What is the average Female students (as % of total students) of Japan per year?
Provide a short and direct response. 48.85. In the year 2005, what is the difference between the Female students (as % of total students) in Chile and Female students (as % of total students) in Hong Kong?
Provide a short and direct response. 0.53. In the year 2005, what is the difference between the Female students (as % of total students) in Chile and Female students (as % of total students) in Indonesia?
Provide a succinct answer. 0.5. In the year 2005, what is the difference between the Female students (as % of total students) of Chile and Female students (as % of total students) of Japan?
Your response must be concise. 0.63. In the year 2005, what is the difference between the Female students (as % of total students) of Hong Kong and Female students (as % of total students) of Indonesia?
Provide a short and direct response. -0.03. In the year 2005, what is the difference between the Female students (as % of total students) in Hong Kong and Female students (as % of total students) in Japan?
Ensure brevity in your answer.  0.11. In the year 2005, what is the difference between the Female students (as % of total students) in Indonesia and Female students (as % of total students) in Japan?
Your response must be concise. 0.13. In the year 2006, what is the difference between the Female students (as % of total students) of Chile and Female students (as % of total students) of Hong Kong?
Your answer should be very brief. 0.82. In the year 2006, what is the difference between the Female students (as % of total students) in Chile and Female students (as % of total students) in Indonesia?
Provide a short and direct response. 0.3. In the year 2006, what is the difference between the Female students (as % of total students) of Chile and Female students (as % of total students) of Japan?
Keep it short and to the point. 0.82. In the year 2006, what is the difference between the Female students (as % of total students) of Hong Kong and Female students (as % of total students) of Indonesia?
Your answer should be very brief. -0.51. In the year 2006, what is the difference between the Female students (as % of total students) in Hong Kong and Female students (as % of total students) in Japan?
Your response must be concise. 0. In the year 2006, what is the difference between the Female students (as % of total students) of Indonesia and Female students (as % of total students) of Japan?
Your answer should be compact. 0.52. In the year 2007, what is the difference between the Female students (as % of total students) in Chile and Female students (as % of total students) in Indonesia?
Ensure brevity in your answer.  0.42. In the year 2007, what is the difference between the Female students (as % of total students) in Chile and Female students (as % of total students) in Japan?
Your answer should be compact. 0.94. In the year 2007, what is the difference between the Female students (as % of total students) in Hong Kong and Female students (as % of total students) in Indonesia?
Offer a terse response. -0.58. In the year 2007, what is the difference between the Female students (as % of total students) of Hong Kong and Female students (as % of total students) of Japan?
Offer a very short reply. -0.06. In the year 2007, what is the difference between the Female students (as % of total students) of Indonesia and Female students (as % of total students) of Japan?
Give a very brief answer. 0.52. In the year 2008, what is the difference between the Female students (as % of total students) of Chile and Female students (as % of total students) of Hong Kong?
Your answer should be compact. 1.06. In the year 2008, what is the difference between the Female students (as % of total students) in Chile and Female students (as % of total students) in Indonesia?
Give a very brief answer. 0.77. In the year 2008, what is the difference between the Female students (as % of total students) in Chile and Female students (as % of total students) in Japan?
Keep it short and to the point. 0.95. In the year 2008, what is the difference between the Female students (as % of total students) in Hong Kong and Female students (as % of total students) in Indonesia?
Your answer should be very brief. -0.29. In the year 2008, what is the difference between the Female students (as % of total students) in Hong Kong and Female students (as % of total students) in Japan?
Provide a succinct answer. -0.11. In the year 2008, what is the difference between the Female students (as % of total students) in Indonesia and Female students (as % of total students) in Japan?
Your response must be concise. 0.18. In the year 2009, what is the difference between the Female students (as % of total students) in Chile and Female students (as % of total students) in Hong Kong?
Your response must be concise. 1.14. In the year 2009, what is the difference between the Female students (as % of total students) in Chile and Female students (as % of total students) in Indonesia?
Provide a short and direct response. 0.84. In the year 2009, what is the difference between the Female students (as % of total students) in Chile and Female students (as % of total students) in Japan?
Provide a succinct answer. 0.98. In the year 2009, what is the difference between the Female students (as % of total students) of Hong Kong and Female students (as % of total students) of Indonesia?
Make the answer very short. -0.3. In the year 2009, what is the difference between the Female students (as % of total students) in Hong Kong and Female students (as % of total students) in Japan?
Your answer should be compact. -0.16. In the year 2009, what is the difference between the Female students (as % of total students) in Indonesia and Female students (as % of total students) in Japan?
Your answer should be compact. 0.14. In the year 2010, what is the difference between the Female students (as % of total students) of Chile and Female students (as % of total students) of Hong Kong?
Offer a very short reply. 1.35. In the year 2010, what is the difference between the Female students (as % of total students) of Chile and Female students (as % of total students) of Indonesia?
Make the answer very short. 0.62. In the year 2010, what is the difference between the Female students (as % of total students) in Chile and Female students (as % of total students) in Japan?
Your answer should be compact. 1.03. In the year 2010, what is the difference between the Female students (as % of total students) of Hong Kong and Female students (as % of total students) of Indonesia?
Make the answer very short. -0.73. In the year 2010, what is the difference between the Female students (as % of total students) of Hong Kong and Female students (as % of total students) of Japan?
Offer a very short reply. -0.32. In the year 2010, what is the difference between the Female students (as % of total students) in Indonesia and Female students (as % of total students) in Japan?
Your answer should be very brief. 0.41. In the year 2011, what is the difference between the Female students (as % of total students) in Chile and Female students (as % of total students) in Hong Kong?
Make the answer very short. 1.46. In the year 2011, what is the difference between the Female students (as % of total students) in Chile and Female students (as % of total students) in Indonesia?
Your answer should be very brief. 0.75. In the year 2011, what is the difference between the Female students (as % of total students) of Chile and Female students (as % of total students) of Japan?
Provide a short and direct response. 1.02. In the year 2011, what is the difference between the Female students (as % of total students) of Hong Kong and Female students (as % of total students) of Indonesia?
Provide a short and direct response. -0.72. In the year 2011, what is the difference between the Female students (as % of total students) in Hong Kong and Female students (as % of total students) in Japan?
Keep it short and to the point. -0.45. In the year 2011, what is the difference between the Female students (as % of total students) of Indonesia and Female students (as % of total students) of Japan?
Offer a very short reply. 0.27. In the year 2012, what is the difference between the Female students (as % of total students) of Chile and Female students (as % of total students) of Hong Kong?
Your answer should be very brief. 1.65. In the year 2012, what is the difference between the Female students (as % of total students) of Chile and Female students (as % of total students) of Indonesia?
Your answer should be compact. 0.44. In the year 2012, what is the difference between the Female students (as % of total students) in Chile and Female students (as % of total students) in Japan?
Provide a short and direct response. 1.12. In the year 2012, what is the difference between the Female students (as % of total students) in Hong Kong and Female students (as % of total students) in Indonesia?
Your answer should be compact. -1.21. In the year 2012, what is the difference between the Female students (as % of total students) of Hong Kong and Female students (as % of total students) of Japan?
Offer a terse response. -0.53. In the year 2012, what is the difference between the Female students (as % of total students) of Indonesia and Female students (as % of total students) of Japan?
Offer a very short reply. 0.68. What is the ratio of the Female students (as % of total students) of Hong Kong in 2005 to that in 2006?
Give a very brief answer. 1. What is the ratio of the Female students (as % of total students) of Indonesia in 2005 to that in 2006?
Offer a terse response. 0.99. What is the ratio of the Female students (as % of total students) of Hong Kong in 2005 to that in 2007?
Ensure brevity in your answer.  1. What is the ratio of the Female students (as % of total students) of Indonesia in 2005 to that in 2007?
Offer a very short reply. 0.99. What is the ratio of the Female students (as % of total students) in Indonesia in 2005 to that in 2008?
Your answer should be very brief. 1. What is the ratio of the Female students (as % of total students) of Japan in 2005 to that in 2008?
Your answer should be very brief. 1. What is the ratio of the Female students (as % of total students) of Chile in 2005 to that in 2009?
Your answer should be compact. 0.99. What is the ratio of the Female students (as % of total students) of Hong Kong in 2005 to that in 2009?
Make the answer very short. 1. What is the ratio of the Female students (as % of total students) in Hong Kong in 2005 to that in 2010?
Your answer should be compact. 1.01. What is the ratio of the Female students (as % of total students) of Indonesia in 2005 to that in 2010?
Your response must be concise. 0.99. What is the ratio of the Female students (as % of total students) in Japan in 2005 to that in 2010?
Provide a short and direct response. 1. What is the ratio of the Female students (as % of total students) in Hong Kong in 2005 to that in 2011?
Your response must be concise. 1.01. What is the ratio of the Female students (as % of total students) in Indonesia in 2005 to that in 2011?
Make the answer very short. 1. What is the ratio of the Female students (as % of total students) in Chile in 2005 to that in 2012?
Provide a succinct answer. 0.99. What is the ratio of the Female students (as % of total students) in Hong Kong in 2005 to that in 2012?
Offer a terse response. 1.01. What is the ratio of the Female students (as % of total students) of Hong Kong in 2006 to that in 2007?
Offer a very short reply. 1. What is the ratio of the Female students (as % of total students) of Indonesia in 2006 to that in 2007?
Offer a very short reply. 1. What is the ratio of the Female students (as % of total students) in Japan in 2006 to that in 2007?
Your answer should be compact. 1. What is the ratio of the Female students (as % of total students) in Chile in 2006 to that in 2008?
Keep it short and to the point. 1. What is the ratio of the Female students (as % of total students) of Hong Kong in 2006 to that in 2009?
Your answer should be very brief. 1. What is the ratio of the Female students (as % of total students) in Indonesia in 2006 to that in 2009?
Keep it short and to the point. 1.01. What is the ratio of the Female students (as % of total students) in Japan in 2006 to that in 2009?
Your answer should be compact. 1. What is the ratio of the Female students (as % of total students) in Chile in 2006 to that in 2010?
Your answer should be very brief. 1. What is the ratio of the Female students (as % of total students) in Indonesia in 2006 to that in 2010?
Provide a succinct answer. 1. What is the ratio of the Female students (as % of total students) in Hong Kong in 2006 to that in 2011?
Give a very brief answer. 1.01. What is the ratio of the Female students (as % of total students) in Indonesia in 2006 to that in 2011?
Your answer should be very brief. 1. What is the ratio of the Female students (as % of total students) in Chile in 2006 to that in 2012?
Your answer should be compact. 0.99. What is the ratio of the Female students (as % of total students) in Hong Kong in 2006 to that in 2012?
Offer a very short reply. 1.01. What is the ratio of the Female students (as % of total students) in Indonesia in 2006 to that in 2012?
Keep it short and to the point. 1. What is the ratio of the Female students (as % of total students) in Japan in 2006 to that in 2012?
Offer a very short reply. 1. What is the ratio of the Female students (as % of total students) in Chile in 2007 to that in 2008?
Keep it short and to the point. 1. What is the ratio of the Female students (as % of total students) of Hong Kong in 2007 to that in 2008?
Provide a succinct answer. 1. What is the ratio of the Female students (as % of total students) of Indonesia in 2007 to that in 2008?
Give a very brief answer. 1.01. What is the ratio of the Female students (as % of total students) of Japan in 2007 to that in 2008?
Keep it short and to the point. 1. What is the ratio of the Female students (as % of total students) of Hong Kong in 2007 to that in 2009?
Offer a terse response. 1. What is the ratio of the Female students (as % of total students) in Indonesia in 2007 to that in 2009?
Offer a very short reply. 1.01. What is the ratio of the Female students (as % of total students) in Chile in 2007 to that in 2010?
Ensure brevity in your answer.  1. What is the ratio of the Female students (as % of total students) of Hong Kong in 2007 to that in 2010?
Offer a terse response. 1. What is the ratio of the Female students (as % of total students) of Hong Kong in 2007 to that in 2011?
Your response must be concise. 1.01. What is the ratio of the Female students (as % of total students) of Indonesia in 2007 to that in 2011?
Make the answer very short. 1. What is the ratio of the Female students (as % of total students) of Hong Kong in 2007 to that in 2012?
Make the answer very short. 1.01. What is the ratio of the Female students (as % of total students) in Indonesia in 2008 to that in 2009?
Offer a terse response. 1. What is the ratio of the Female students (as % of total students) in Chile in 2008 to that in 2010?
Keep it short and to the point. 1. What is the ratio of the Female students (as % of total students) of Hong Kong in 2008 to that in 2010?
Provide a succinct answer. 1. What is the ratio of the Female students (as % of total students) in Japan in 2008 to that in 2010?
Offer a very short reply. 1. What is the ratio of the Female students (as % of total students) in Chile in 2008 to that in 2012?
Your answer should be very brief. 1. What is the ratio of the Female students (as % of total students) in Hong Kong in 2008 to that in 2012?
Your answer should be compact. 1.01. What is the ratio of the Female students (as % of total students) in Indonesia in 2008 to that in 2012?
Ensure brevity in your answer.  0.99. What is the ratio of the Female students (as % of total students) of Chile in 2009 to that in 2011?
Provide a succinct answer. 1. What is the ratio of the Female students (as % of total students) in Hong Kong in 2009 to that in 2011?
Your answer should be compact. 1.01. What is the ratio of the Female students (as % of total students) in Japan in 2009 to that in 2011?
Provide a short and direct response. 1. What is the ratio of the Female students (as % of total students) in Chile in 2009 to that in 2012?
Provide a succinct answer. 1. What is the ratio of the Female students (as % of total students) of Hong Kong in 2009 to that in 2012?
Provide a succinct answer. 1.01. What is the ratio of the Female students (as % of total students) of Indonesia in 2009 to that in 2012?
Make the answer very short. 0.99. What is the ratio of the Female students (as % of total students) in Japan in 2009 to that in 2012?
Your response must be concise. 1. What is the ratio of the Female students (as % of total students) of Japan in 2010 to that in 2011?
Provide a short and direct response. 1. What is the ratio of the Female students (as % of total students) in Chile in 2010 to that in 2012?
Offer a very short reply. 1. What is the ratio of the Female students (as % of total students) of Hong Kong in 2010 to that in 2012?
Keep it short and to the point. 1. What is the ratio of the Female students (as % of total students) of Japan in 2010 to that in 2012?
Ensure brevity in your answer.  1. What is the ratio of the Female students (as % of total students) in Japan in 2011 to that in 2012?
Your answer should be very brief. 1. What is the difference between the highest and the second highest Female students (as % of total students) in Chile?
Your response must be concise. 0.12. What is the difference between the highest and the second highest Female students (as % of total students) in Hong Kong?
Your response must be concise. 0.11. What is the difference between the highest and the second highest Female students (as % of total students) of Indonesia?
Offer a very short reply. 0.21. What is the difference between the highest and the second highest Female students (as % of total students) of Japan?
Your answer should be very brief. 0.02. What is the difference between the highest and the lowest Female students (as % of total students) of Chile?
Keep it short and to the point. 0.54. What is the difference between the highest and the lowest Female students (as % of total students) of Hong Kong?
Ensure brevity in your answer.  0.59. What is the difference between the highest and the lowest Female students (as % of total students) of Indonesia?
Your response must be concise. 0.6. What is the difference between the highest and the lowest Female students (as % of total students) of Japan?
Ensure brevity in your answer.  0.06. 